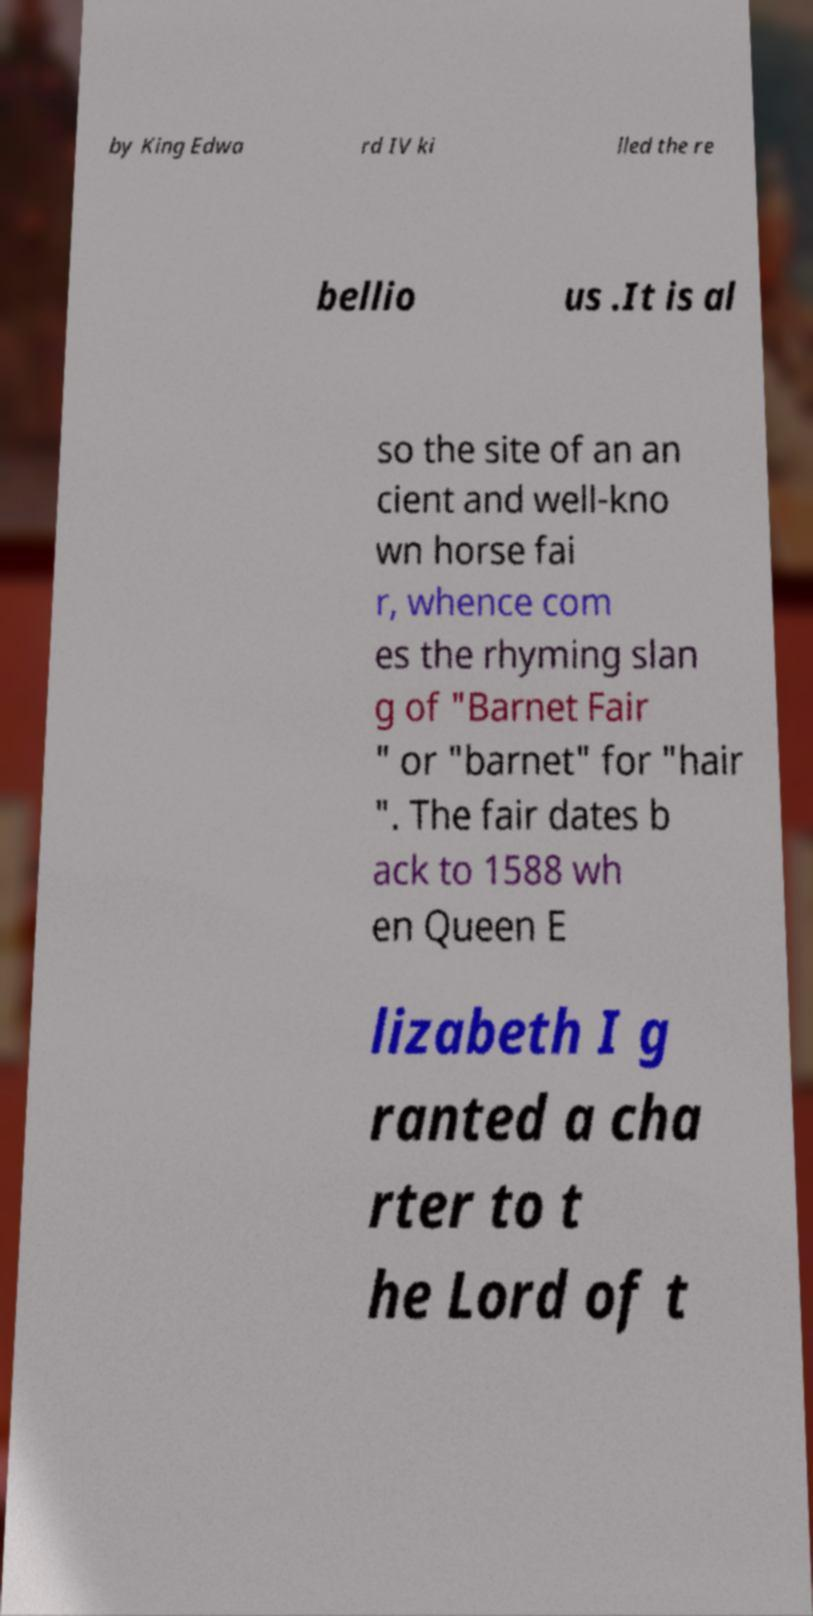What messages or text are displayed in this image? I need them in a readable, typed format. by King Edwa rd IV ki lled the re bellio us .It is al so the site of an an cient and well-kno wn horse fai r, whence com es the rhyming slan g of "Barnet Fair " or "barnet" for "hair ". The fair dates b ack to 1588 wh en Queen E lizabeth I g ranted a cha rter to t he Lord of t 